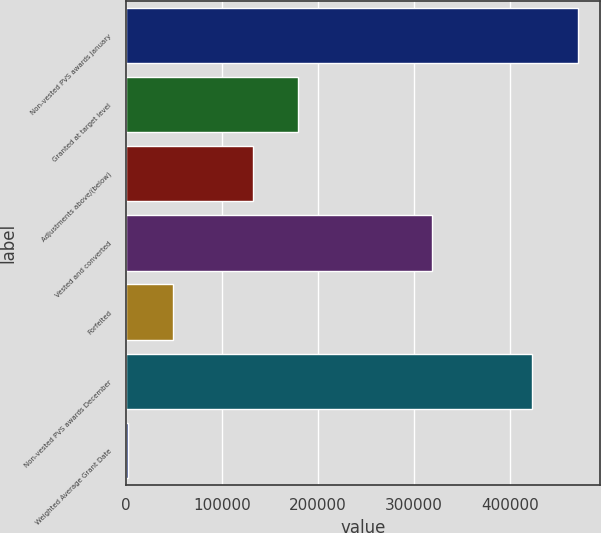<chart> <loc_0><loc_0><loc_500><loc_500><bar_chart><fcel>Non-vested PVS awards January<fcel>Granted at target level<fcel>Adjustments above/(below)<fcel>Vested and converted<fcel>Forfeited<fcel>Non-vested PVS awards December<fcel>Weighted Average Grant Date<nl><fcel>470719<fcel>179314<fcel>132444<fcel>318337<fcel>48885.4<fcel>422726<fcel>2015<nl></chart> 